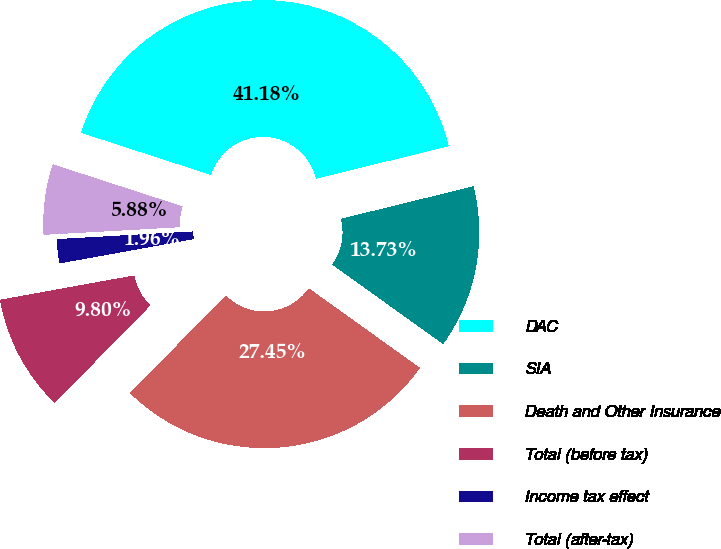<chart> <loc_0><loc_0><loc_500><loc_500><pie_chart><fcel>DAC<fcel>SIA<fcel>Death and Other Insurance<fcel>Total (before tax)<fcel>Income tax effect<fcel>Total (after-tax)<nl><fcel>41.18%<fcel>13.73%<fcel>27.45%<fcel>9.8%<fcel>1.96%<fcel>5.88%<nl></chart> 